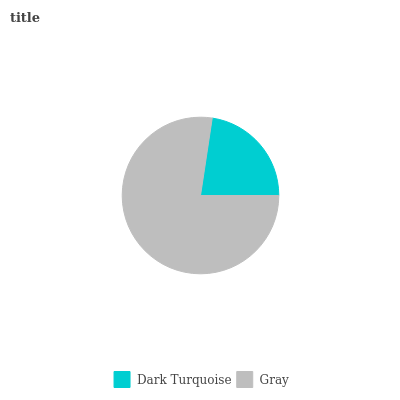Is Dark Turquoise the minimum?
Answer yes or no. Yes. Is Gray the maximum?
Answer yes or no. Yes. Is Gray the minimum?
Answer yes or no. No. Is Gray greater than Dark Turquoise?
Answer yes or no. Yes. Is Dark Turquoise less than Gray?
Answer yes or no. Yes. Is Dark Turquoise greater than Gray?
Answer yes or no. No. Is Gray less than Dark Turquoise?
Answer yes or no. No. Is Gray the high median?
Answer yes or no. Yes. Is Dark Turquoise the low median?
Answer yes or no. Yes. Is Dark Turquoise the high median?
Answer yes or no. No. Is Gray the low median?
Answer yes or no. No. 